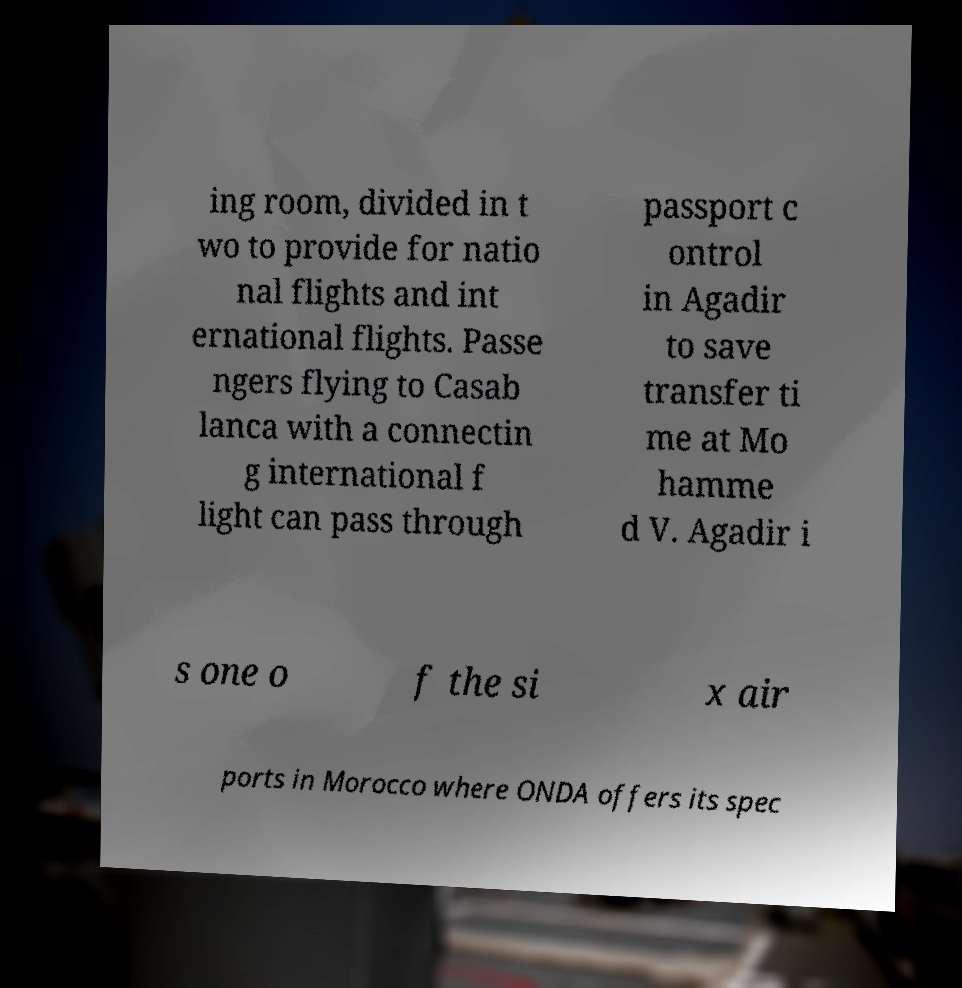I need the written content from this picture converted into text. Can you do that? ing room, divided in t wo to provide for natio nal flights and int ernational flights. Passe ngers flying to Casab lanca with a connectin g international f light can pass through passport c ontrol in Agadir to save transfer ti me at Mo hamme d V. Agadir i s one o f the si x air ports in Morocco where ONDA offers its spec 